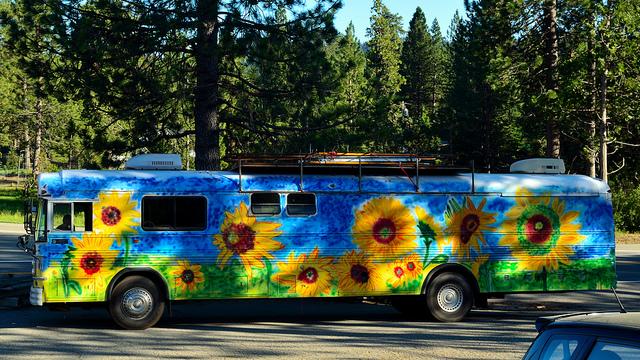What is the pattern and color on the bus?
Concise answer only. Floral. What objects are painted on the bus?
Quick response, please. Flowers. Is the bus moving?
Quick response, please. No. 